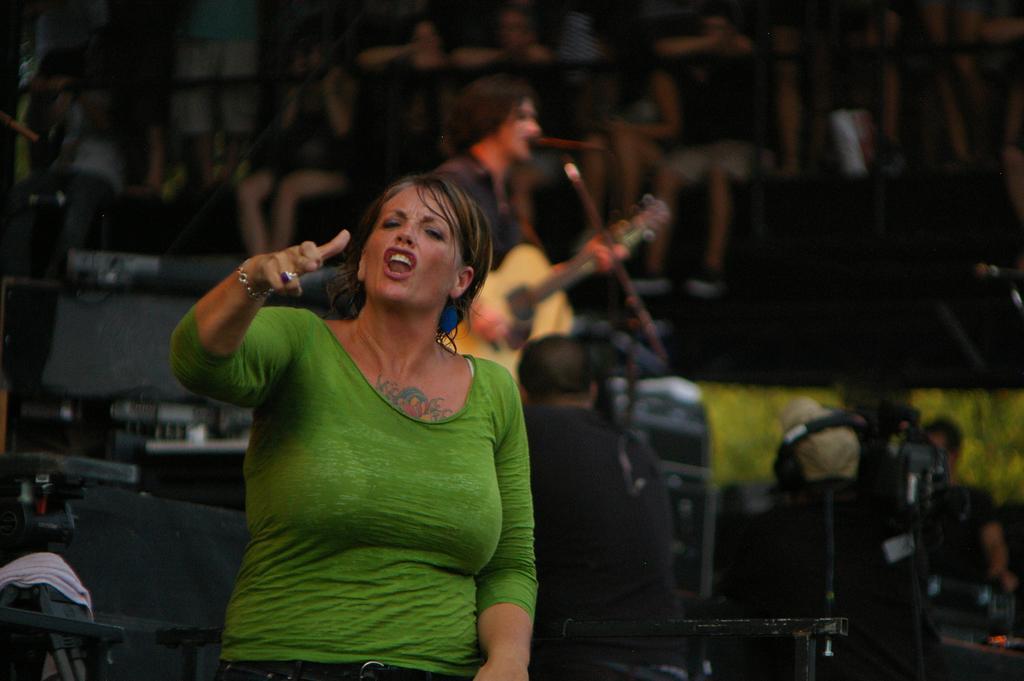Could you give a brief overview of what you see in this image? In this image I see a woman who is wearing green top and I see that it is blurred in the background and I see number of people and I see that this person is holding a guitar in hands. 